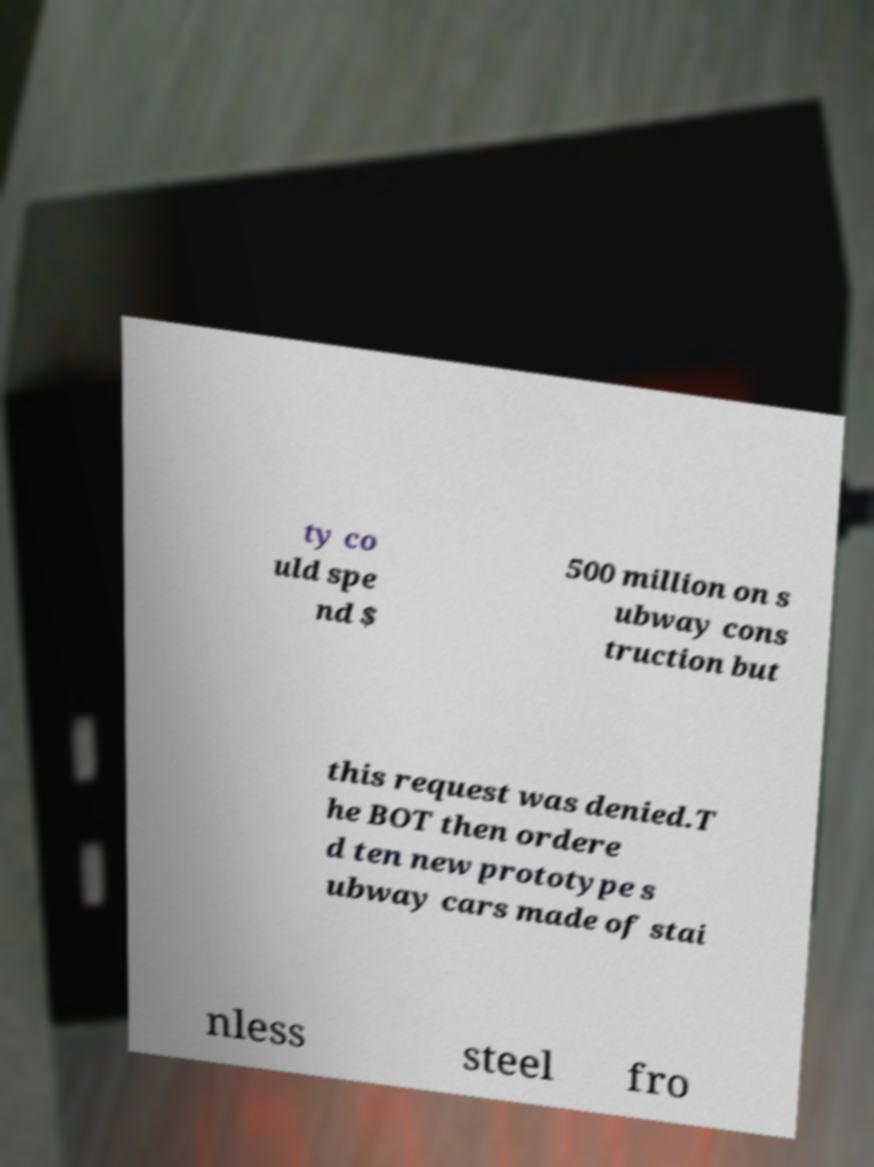Could you extract and type out the text from this image? ty co uld spe nd $ 500 million on s ubway cons truction but this request was denied.T he BOT then ordere d ten new prototype s ubway cars made of stai nless steel fro 